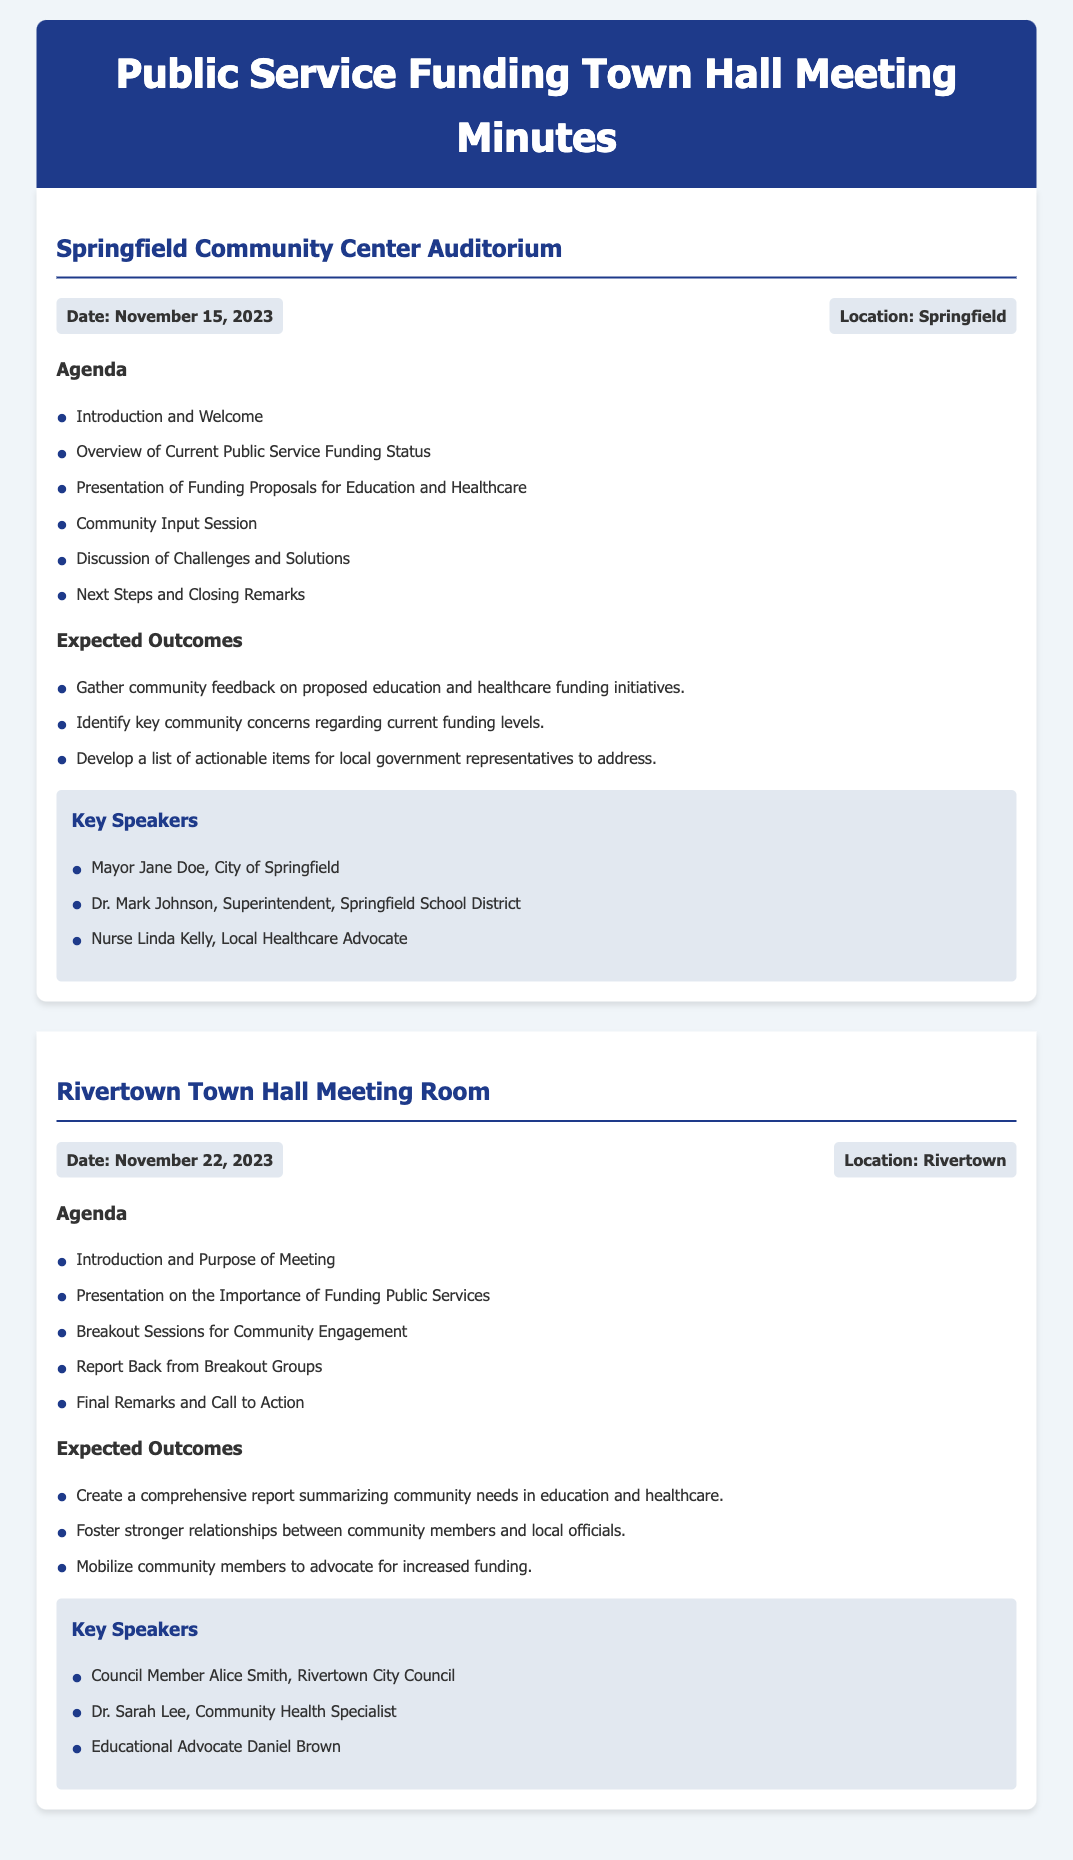What is the date of the Springfield meeting? The document states the date for the Springfield meeting as November 15, 2023.
Answer: November 15, 2023 Who is the key speaker from the Springfield School District? The document lists Dr. Mark Johnson as the key speaker from the Springfield School District.
Answer: Dr. Mark Johnson What is one expected outcome of the Rivertown meeting? The document mentions creating a comprehensive report summarizing community needs in education and healthcare as an expected outcome.
Answer: Create a comprehensive report How many key speakers are listed for the Rivertown meeting? The document indicates there are three key speakers listed for Rivertown meeting.
Answer: Three What is the location of the Rivertown meeting? The document specifies that the location for the Rivertown meeting is Rivertown.
Answer: Rivertown What is the purpose of breakout sessions in the Rivertown agenda? The purpose is to foster community engagement as indicated in the agenda.
Answer: Community Engagement What time of year are the town hall meetings scheduled? The meetings are scheduled in November, as stated in the document.
Answer: November Who is the local healthcare advocate in Springfield? The document lists Nurse Linda Kelly as the local healthcare advocate.
Answer: Nurse Linda Kelly 